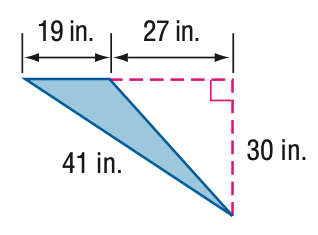Answer the mathemtical geometry problem and directly provide the correct option letter.
Question: Find the perimeter of the triangle.
Choices: A: 87 B: 90 C: 95 D: 100.4 D 